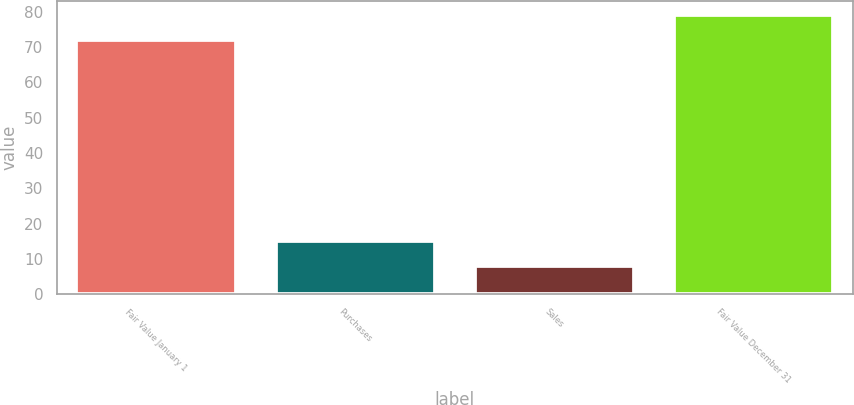<chart> <loc_0><loc_0><loc_500><loc_500><bar_chart><fcel>Fair Value January 1<fcel>Purchases<fcel>Sales<fcel>Fair Value December 31<nl><fcel>72<fcel>15<fcel>8<fcel>79<nl></chart> 